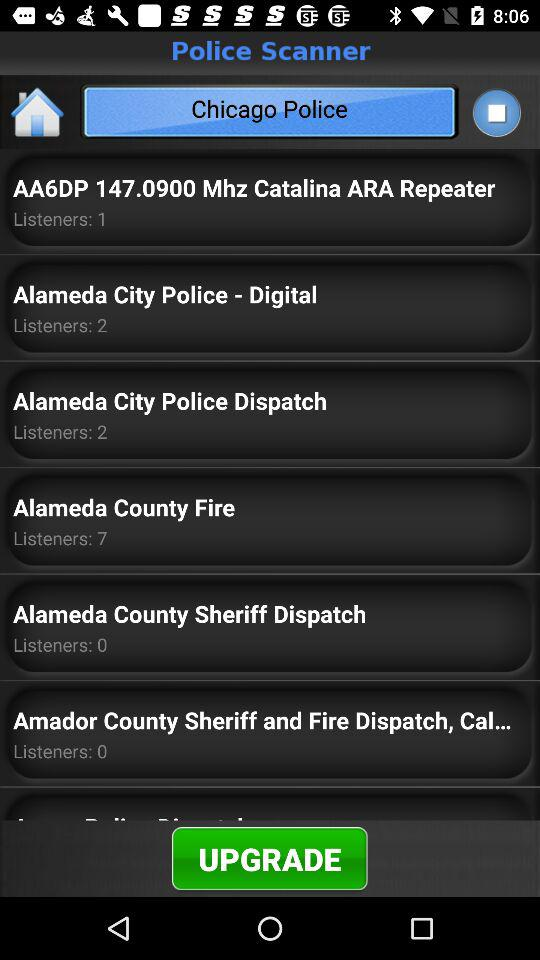What is the application name? The application name is "Police Scanner". 